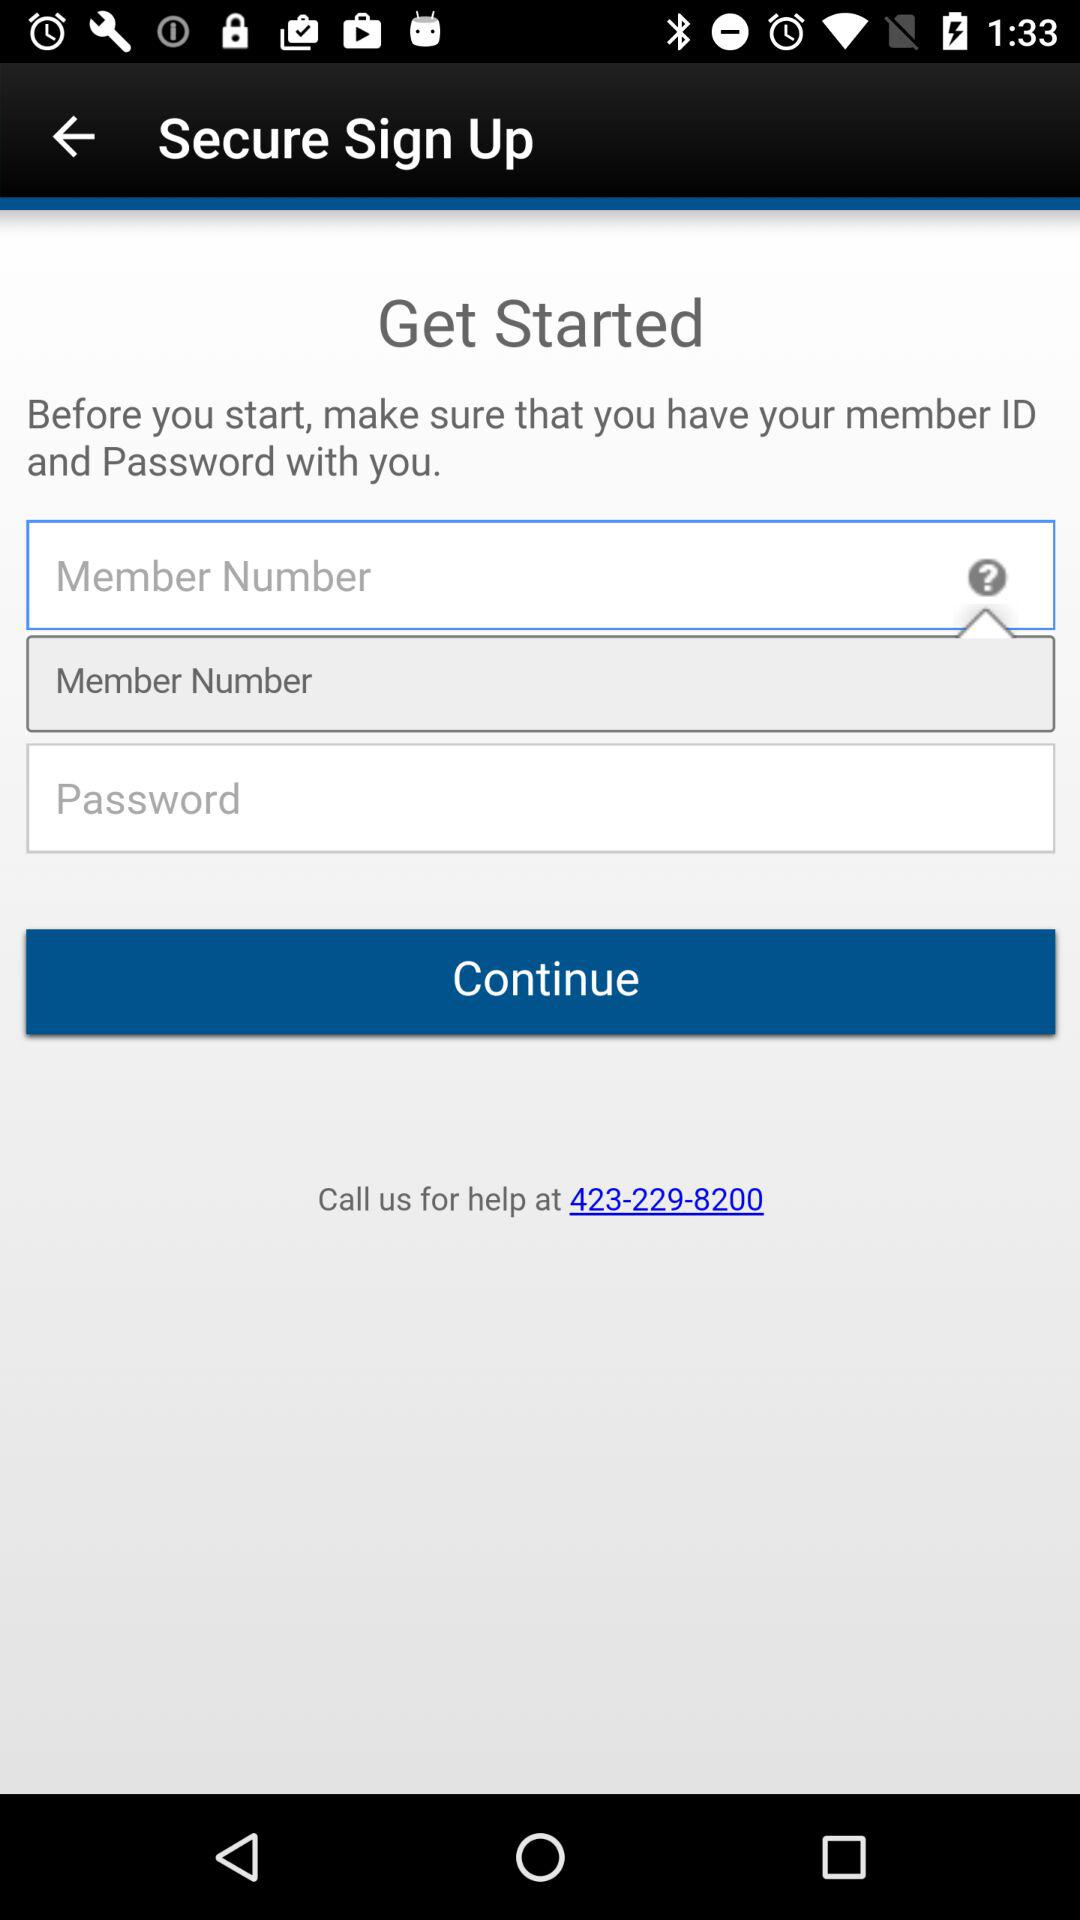What is the contact number for help? The contact number for help is 423-229-8200. 